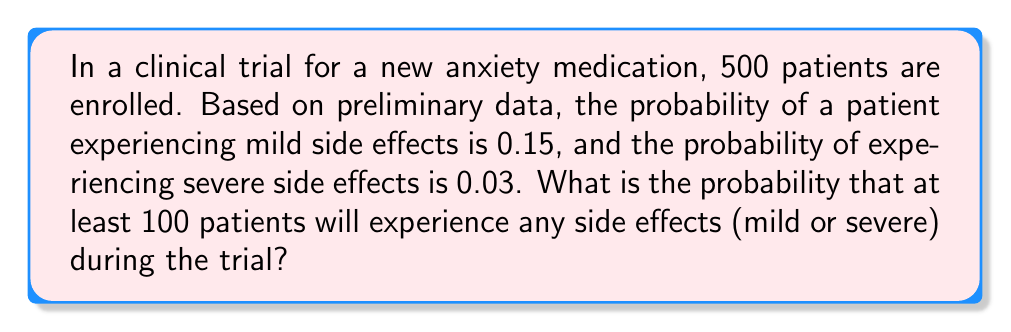Show me your answer to this math problem. Let's approach this step-by-step:

1) First, we need to find the probability of a patient experiencing any side effects:
   $P(\text{any side effects}) = P(\text{mild}) + P(\text{severe}) = 0.15 + 0.03 = 0.18$

2) Now, we can model this as a binomial distribution. We want to find the probability of at least 100 patients experiencing side effects out of 500 patients.

3) Let X be the number of patients experiencing side effects. Then:
   $X \sim \text{Binomial}(n=500, p=0.18)$

4) We want to find $P(X \geq 100)$. It's often easier to calculate this as:
   $P(X \geq 100) = 1 - P(X < 100) = 1 - P(X \leq 99)$

5) For large n and np > 5 (which is true in this case), we can approximate the binomial distribution with a normal distribution:
   $X \approx N(\mu = np, \sigma^2 = np(1-p))$

6) Calculate $\mu$ and $\sigma$:
   $\mu = 500 * 0.18 = 90$
   $\sigma = \sqrt{500 * 0.18 * 0.82} = \sqrt{73.8} \approx 8.59$

7) Now we can standardize our Z-score:
   $Z = \frac{99.5 - 90}{8.59} \approx 1.11$
   (We use 99.5 instead of 99 for continuity correction)

8) Using a standard normal table or calculator, we can find:
   $P(Z \leq 1.11) \approx 0.8665$

9) Therefore, $P(X \geq 100) = 1 - 0.8665 = 0.1335$
Answer: $0.1335$ or $13.35\%$ 